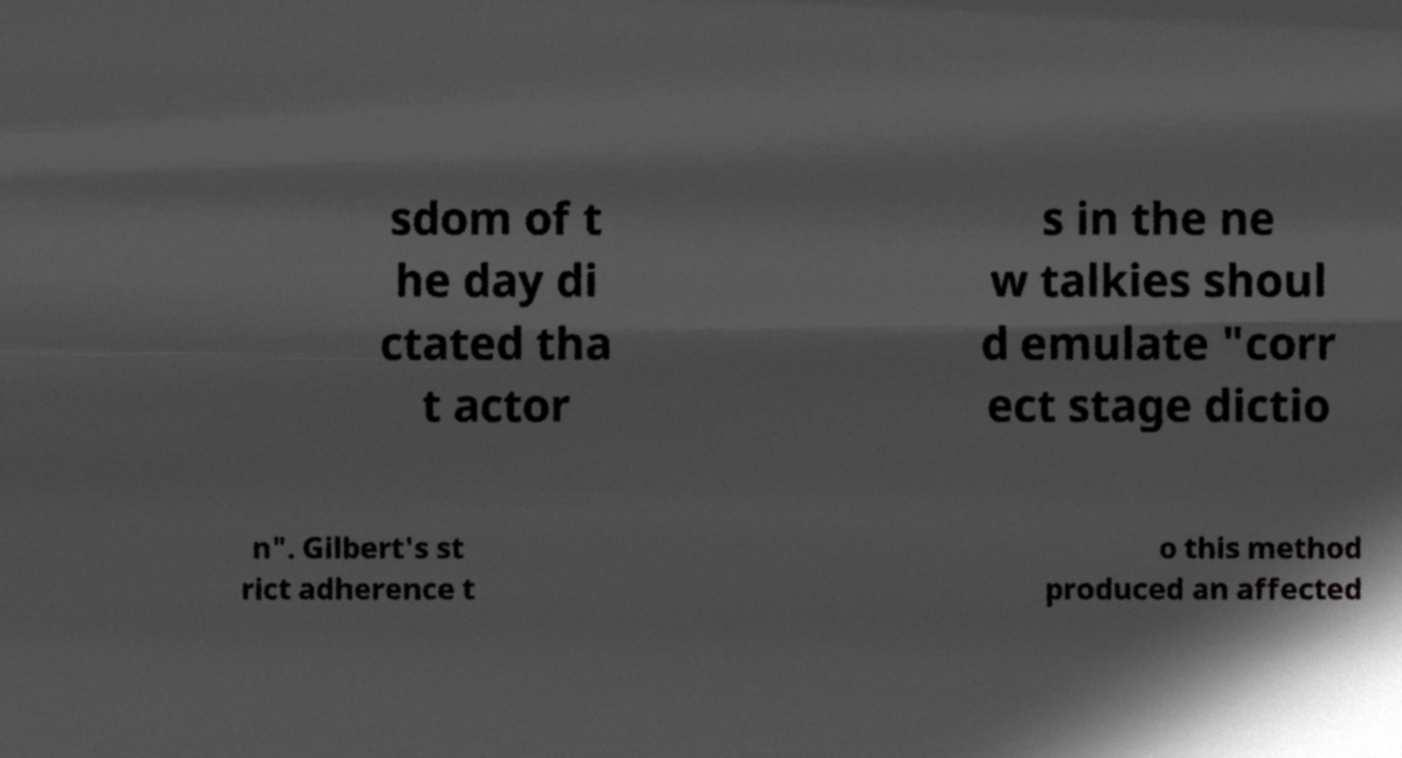Could you assist in decoding the text presented in this image and type it out clearly? sdom of t he day di ctated tha t actor s in the ne w talkies shoul d emulate "corr ect stage dictio n". Gilbert's st rict adherence t o this method produced an affected 